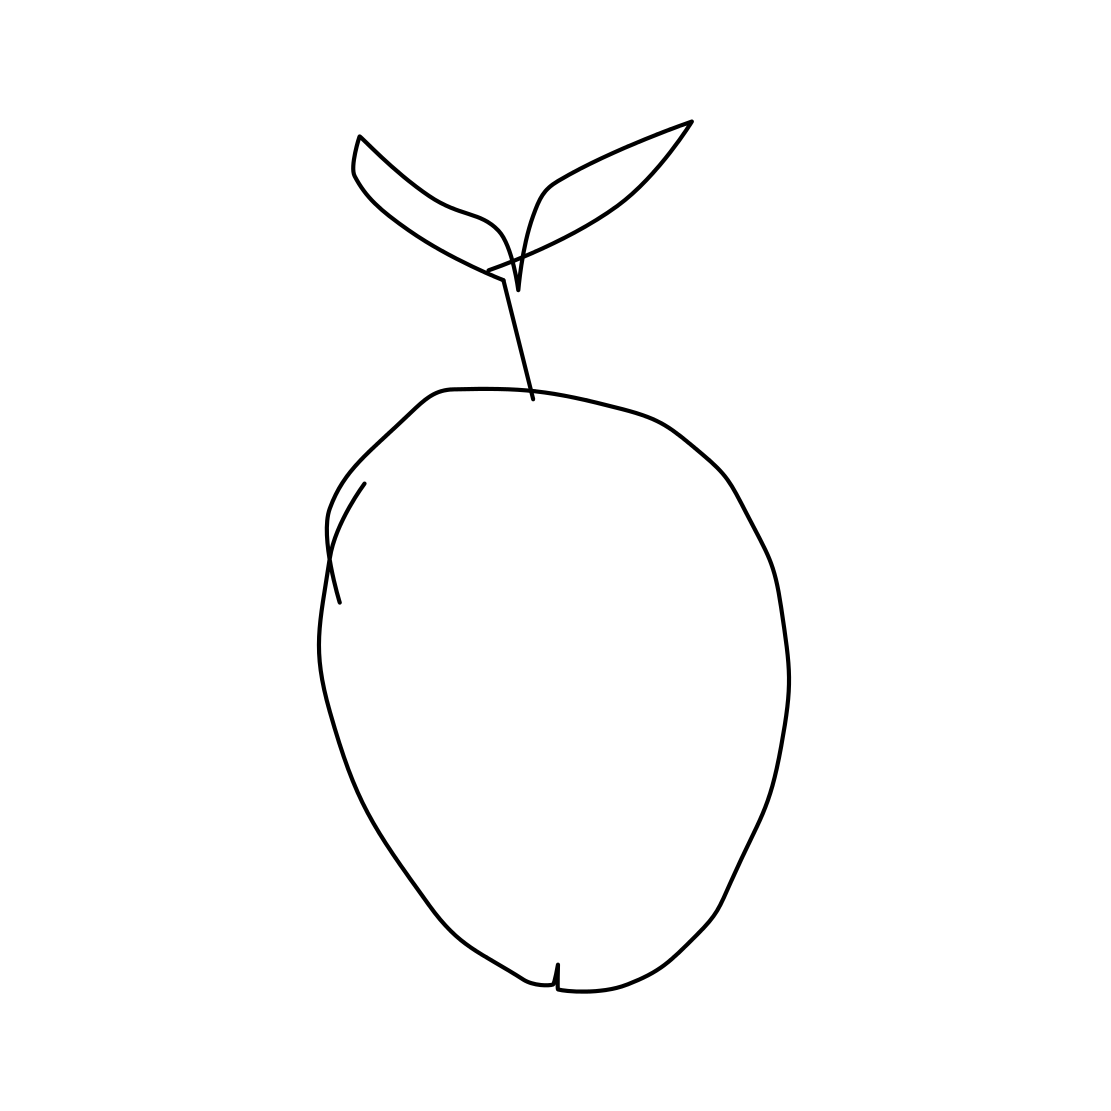What type of fruit is depicted in this image? The image depicts an apple, characterized by its rounded shape and distinct stem with leaves. 